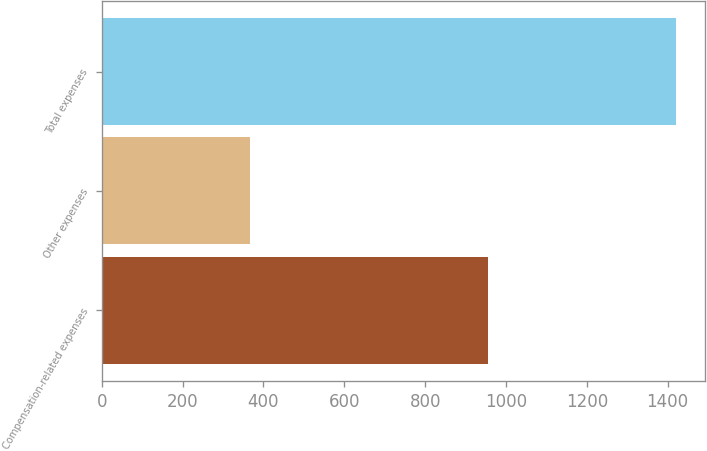<chart> <loc_0><loc_0><loc_500><loc_500><bar_chart><fcel>Compensation-related expenses<fcel>Other expenses<fcel>Total expenses<nl><fcel>955.8<fcel>367.4<fcel>1421.4<nl></chart> 